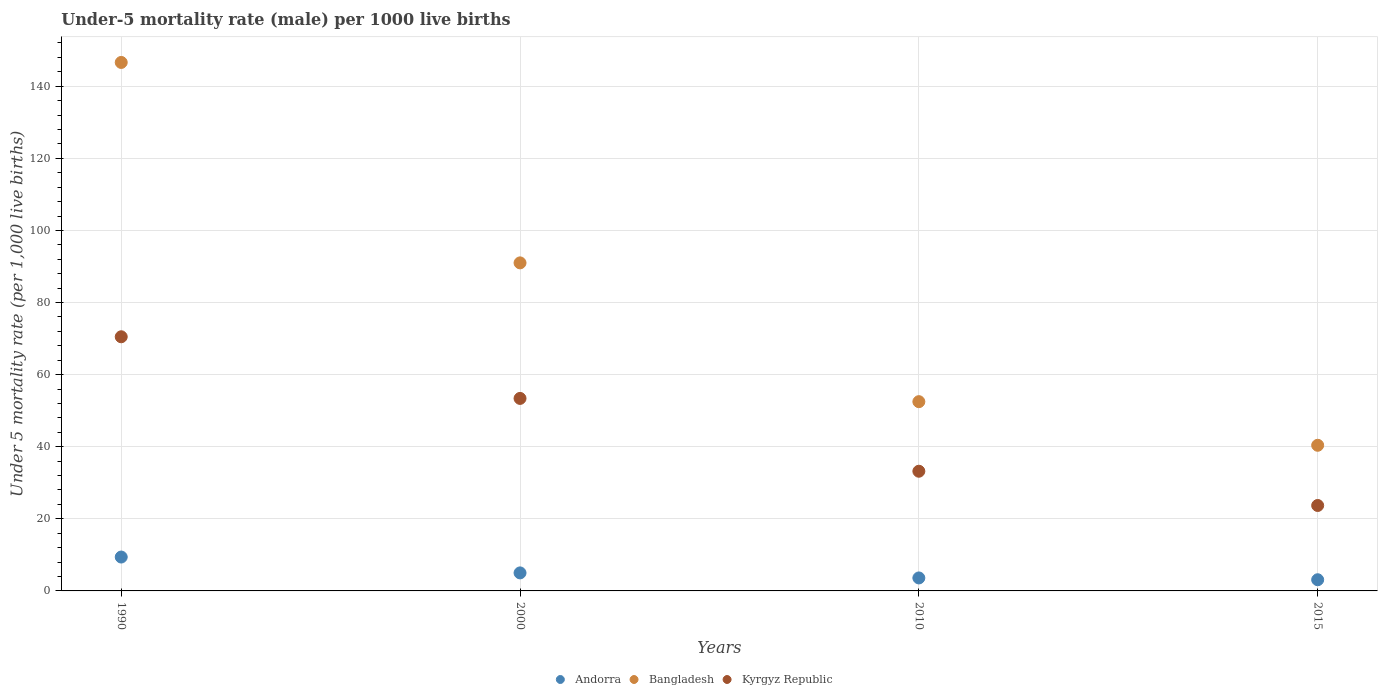How many different coloured dotlines are there?
Offer a very short reply. 3. What is the under-five mortality rate in Andorra in 2015?
Your response must be concise. 3.1. Across all years, what is the maximum under-five mortality rate in Kyrgyz Republic?
Your response must be concise. 70.5. Across all years, what is the minimum under-five mortality rate in Kyrgyz Republic?
Your answer should be compact. 23.7. In which year was the under-five mortality rate in Andorra maximum?
Offer a very short reply. 1990. In which year was the under-five mortality rate in Kyrgyz Republic minimum?
Your answer should be compact. 2015. What is the total under-five mortality rate in Andorra in the graph?
Offer a very short reply. 21.1. What is the difference between the under-five mortality rate in Bangladesh in 2010 and that in 2015?
Provide a short and direct response. 12.1. What is the difference between the under-five mortality rate in Andorra in 2000 and the under-five mortality rate in Kyrgyz Republic in 1990?
Keep it short and to the point. -65.5. What is the average under-five mortality rate in Andorra per year?
Provide a succinct answer. 5.28. In the year 2015, what is the difference between the under-five mortality rate in Bangladesh and under-five mortality rate in Andorra?
Offer a terse response. 37.3. In how many years, is the under-five mortality rate in Bangladesh greater than 36?
Keep it short and to the point. 4. What is the ratio of the under-five mortality rate in Kyrgyz Republic in 2000 to that in 2010?
Provide a short and direct response. 1.61. Is the under-five mortality rate in Kyrgyz Republic in 2000 less than that in 2015?
Offer a very short reply. No. Is the difference between the under-five mortality rate in Bangladesh in 2000 and 2010 greater than the difference between the under-five mortality rate in Andorra in 2000 and 2010?
Make the answer very short. Yes. What is the difference between the highest and the lowest under-five mortality rate in Andorra?
Offer a terse response. 6.3. Is the sum of the under-five mortality rate in Andorra in 1990 and 2015 greater than the maximum under-five mortality rate in Kyrgyz Republic across all years?
Your answer should be very brief. No. Is it the case that in every year, the sum of the under-five mortality rate in Andorra and under-five mortality rate in Bangladesh  is greater than the under-five mortality rate in Kyrgyz Republic?
Provide a succinct answer. Yes. Is the under-five mortality rate in Andorra strictly less than the under-five mortality rate in Bangladesh over the years?
Keep it short and to the point. Yes. How many dotlines are there?
Make the answer very short. 3. Does the graph contain grids?
Give a very brief answer. Yes. Where does the legend appear in the graph?
Make the answer very short. Bottom center. How are the legend labels stacked?
Give a very brief answer. Horizontal. What is the title of the graph?
Ensure brevity in your answer.  Under-5 mortality rate (male) per 1000 live births. What is the label or title of the X-axis?
Keep it short and to the point. Years. What is the label or title of the Y-axis?
Your answer should be compact. Under 5 mortality rate (per 1,0 live births). What is the Under 5 mortality rate (per 1,000 live births) of Andorra in 1990?
Offer a very short reply. 9.4. What is the Under 5 mortality rate (per 1,000 live births) of Bangladesh in 1990?
Your response must be concise. 146.6. What is the Under 5 mortality rate (per 1,000 live births) in Kyrgyz Republic in 1990?
Give a very brief answer. 70.5. What is the Under 5 mortality rate (per 1,000 live births) in Andorra in 2000?
Offer a terse response. 5. What is the Under 5 mortality rate (per 1,000 live births) in Bangladesh in 2000?
Ensure brevity in your answer.  91. What is the Under 5 mortality rate (per 1,000 live births) of Kyrgyz Republic in 2000?
Your answer should be very brief. 53.4. What is the Under 5 mortality rate (per 1,000 live births) of Bangladesh in 2010?
Make the answer very short. 52.5. What is the Under 5 mortality rate (per 1,000 live births) of Kyrgyz Republic in 2010?
Your answer should be very brief. 33.2. What is the Under 5 mortality rate (per 1,000 live births) in Bangladesh in 2015?
Offer a terse response. 40.4. What is the Under 5 mortality rate (per 1,000 live births) of Kyrgyz Republic in 2015?
Keep it short and to the point. 23.7. Across all years, what is the maximum Under 5 mortality rate (per 1,000 live births) in Andorra?
Give a very brief answer. 9.4. Across all years, what is the maximum Under 5 mortality rate (per 1,000 live births) of Bangladesh?
Your response must be concise. 146.6. Across all years, what is the maximum Under 5 mortality rate (per 1,000 live births) in Kyrgyz Republic?
Provide a succinct answer. 70.5. Across all years, what is the minimum Under 5 mortality rate (per 1,000 live births) in Andorra?
Your response must be concise. 3.1. Across all years, what is the minimum Under 5 mortality rate (per 1,000 live births) of Bangladesh?
Ensure brevity in your answer.  40.4. Across all years, what is the minimum Under 5 mortality rate (per 1,000 live births) of Kyrgyz Republic?
Your answer should be very brief. 23.7. What is the total Under 5 mortality rate (per 1,000 live births) in Andorra in the graph?
Provide a short and direct response. 21.1. What is the total Under 5 mortality rate (per 1,000 live births) of Bangladesh in the graph?
Give a very brief answer. 330.5. What is the total Under 5 mortality rate (per 1,000 live births) of Kyrgyz Republic in the graph?
Provide a short and direct response. 180.8. What is the difference between the Under 5 mortality rate (per 1,000 live births) in Bangladesh in 1990 and that in 2000?
Make the answer very short. 55.6. What is the difference between the Under 5 mortality rate (per 1,000 live births) of Kyrgyz Republic in 1990 and that in 2000?
Provide a succinct answer. 17.1. What is the difference between the Under 5 mortality rate (per 1,000 live births) of Andorra in 1990 and that in 2010?
Provide a succinct answer. 5.8. What is the difference between the Under 5 mortality rate (per 1,000 live births) in Bangladesh in 1990 and that in 2010?
Your answer should be compact. 94.1. What is the difference between the Under 5 mortality rate (per 1,000 live births) of Kyrgyz Republic in 1990 and that in 2010?
Offer a very short reply. 37.3. What is the difference between the Under 5 mortality rate (per 1,000 live births) in Bangladesh in 1990 and that in 2015?
Your answer should be compact. 106.2. What is the difference between the Under 5 mortality rate (per 1,000 live births) of Kyrgyz Republic in 1990 and that in 2015?
Offer a terse response. 46.8. What is the difference between the Under 5 mortality rate (per 1,000 live births) of Andorra in 2000 and that in 2010?
Give a very brief answer. 1.4. What is the difference between the Under 5 mortality rate (per 1,000 live births) of Bangladesh in 2000 and that in 2010?
Your answer should be compact. 38.5. What is the difference between the Under 5 mortality rate (per 1,000 live births) of Kyrgyz Republic in 2000 and that in 2010?
Provide a short and direct response. 20.2. What is the difference between the Under 5 mortality rate (per 1,000 live births) of Andorra in 2000 and that in 2015?
Provide a short and direct response. 1.9. What is the difference between the Under 5 mortality rate (per 1,000 live births) in Bangladesh in 2000 and that in 2015?
Provide a short and direct response. 50.6. What is the difference between the Under 5 mortality rate (per 1,000 live births) of Kyrgyz Republic in 2000 and that in 2015?
Keep it short and to the point. 29.7. What is the difference between the Under 5 mortality rate (per 1,000 live births) of Andorra in 2010 and that in 2015?
Offer a terse response. 0.5. What is the difference between the Under 5 mortality rate (per 1,000 live births) in Bangladesh in 2010 and that in 2015?
Keep it short and to the point. 12.1. What is the difference between the Under 5 mortality rate (per 1,000 live births) of Kyrgyz Republic in 2010 and that in 2015?
Provide a succinct answer. 9.5. What is the difference between the Under 5 mortality rate (per 1,000 live births) of Andorra in 1990 and the Under 5 mortality rate (per 1,000 live births) of Bangladesh in 2000?
Offer a terse response. -81.6. What is the difference between the Under 5 mortality rate (per 1,000 live births) of Andorra in 1990 and the Under 5 mortality rate (per 1,000 live births) of Kyrgyz Republic in 2000?
Your answer should be compact. -44. What is the difference between the Under 5 mortality rate (per 1,000 live births) in Bangladesh in 1990 and the Under 5 mortality rate (per 1,000 live births) in Kyrgyz Republic in 2000?
Provide a succinct answer. 93.2. What is the difference between the Under 5 mortality rate (per 1,000 live births) of Andorra in 1990 and the Under 5 mortality rate (per 1,000 live births) of Bangladesh in 2010?
Offer a terse response. -43.1. What is the difference between the Under 5 mortality rate (per 1,000 live births) in Andorra in 1990 and the Under 5 mortality rate (per 1,000 live births) in Kyrgyz Republic in 2010?
Give a very brief answer. -23.8. What is the difference between the Under 5 mortality rate (per 1,000 live births) of Bangladesh in 1990 and the Under 5 mortality rate (per 1,000 live births) of Kyrgyz Republic in 2010?
Provide a succinct answer. 113.4. What is the difference between the Under 5 mortality rate (per 1,000 live births) of Andorra in 1990 and the Under 5 mortality rate (per 1,000 live births) of Bangladesh in 2015?
Give a very brief answer. -31. What is the difference between the Under 5 mortality rate (per 1,000 live births) of Andorra in 1990 and the Under 5 mortality rate (per 1,000 live births) of Kyrgyz Republic in 2015?
Keep it short and to the point. -14.3. What is the difference between the Under 5 mortality rate (per 1,000 live births) of Bangladesh in 1990 and the Under 5 mortality rate (per 1,000 live births) of Kyrgyz Republic in 2015?
Provide a succinct answer. 122.9. What is the difference between the Under 5 mortality rate (per 1,000 live births) in Andorra in 2000 and the Under 5 mortality rate (per 1,000 live births) in Bangladesh in 2010?
Give a very brief answer. -47.5. What is the difference between the Under 5 mortality rate (per 1,000 live births) of Andorra in 2000 and the Under 5 mortality rate (per 1,000 live births) of Kyrgyz Republic in 2010?
Offer a terse response. -28.2. What is the difference between the Under 5 mortality rate (per 1,000 live births) of Bangladesh in 2000 and the Under 5 mortality rate (per 1,000 live births) of Kyrgyz Republic in 2010?
Ensure brevity in your answer.  57.8. What is the difference between the Under 5 mortality rate (per 1,000 live births) in Andorra in 2000 and the Under 5 mortality rate (per 1,000 live births) in Bangladesh in 2015?
Provide a succinct answer. -35.4. What is the difference between the Under 5 mortality rate (per 1,000 live births) in Andorra in 2000 and the Under 5 mortality rate (per 1,000 live births) in Kyrgyz Republic in 2015?
Offer a very short reply. -18.7. What is the difference between the Under 5 mortality rate (per 1,000 live births) in Bangladesh in 2000 and the Under 5 mortality rate (per 1,000 live births) in Kyrgyz Republic in 2015?
Your answer should be very brief. 67.3. What is the difference between the Under 5 mortality rate (per 1,000 live births) in Andorra in 2010 and the Under 5 mortality rate (per 1,000 live births) in Bangladesh in 2015?
Your response must be concise. -36.8. What is the difference between the Under 5 mortality rate (per 1,000 live births) of Andorra in 2010 and the Under 5 mortality rate (per 1,000 live births) of Kyrgyz Republic in 2015?
Keep it short and to the point. -20.1. What is the difference between the Under 5 mortality rate (per 1,000 live births) in Bangladesh in 2010 and the Under 5 mortality rate (per 1,000 live births) in Kyrgyz Republic in 2015?
Offer a terse response. 28.8. What is the average Under 5 mortality rate (per 1,000 live births) of Andorra per year?
Offer a terse response. 5.28. What is the average Under 5 mortality rate (per 1,000 live births) of Bangladesh per year?
Provide a succinct answer. 82.62. What is the average Under 5 mortality rate (per 1,000 live births) in Kyrgyz Republic per year?
Make the answer very short. 45.2. In the year 1990, what is the difference between the Under 5 mortality rate (per 1,000 live births) of Andorra and Under 5 mortality rate (per 1,000 live births) of Bangladesh?
Your answer should be compact. -137.2. In the year 1990, what is the difference between the Under 5 mortality rate (per 1,000 live births) of Andorra and Under 5 mortality rate (per 1,000 live births) of Kyrgyz Republic?
Your answer should be compact. -61.1. In the year 1990, what is the difference between the Under 5 mortality rate (per 1,000 live births) of Bangladesh and Under 5 mortality rate (per 1,000 live births) of Kyrgyz Republic?
Ensure brevity in your answer.  76.1. In the year 2000, what is the difference between the Under 5 mortality rate (per 1,000 live births) of Andorra and Under 5 mortality rate (per 1,000 live births) of Bangladesh?
Make the answer very short. -86. In the year 2000, what is the difference between the Under 5 mortality rate (per 1,000 live births) in Andorra and Under 5 mortality rate (per 1,000 live births) in Kyrgyz Republic?
Provide a short and direct response. -48.4. In the year 2000, what is the difference between the Under 5 mortality rate (per 1,000 live births) of Bangladesh and Under 5 mortality rate (per 1,000 live births) of Kyrgyz Republic?
Provide a succinct answer. 37.6. In the year 2010, what is the difference between the Under 5 mortality rate (per 1,000 live births) in Andorra and Under 5 mortality rate (per 1,000 live births) in Bangladesh?
Your answer should be compact. -48.9. In the year 2010, what is the difference between the Under 5 mortality rate (per 1,000 live births) of Andorra and Under 5 mortality rate (per 1,000 live births) of Kyrgyz Republic?
Ensure brevity in your answer.  -29.6. In the year 2010, what is the difference between the Under 5 mortality rate (per 1,000 live births) of Bangladesh and Under 5 mortality rate (per 1,000 live births) of Kyrgyz Republic?
Your answer should be compact. 19.3. In the year 2015, what is the difference between the Under 5 mortality rate (per 1,000 live births) in Andorra and Under 5 mortality rate (per 1,000 live births) in Bangladesh?
Offer a terse response. -37.3. In the year 2015, what is the difference between the Under 5 mortality rate (per 1,000 live births) in Andorra and Under 5 mortality rate (per 1,000 live births) in Kyrgyz Republic?
Give a very brief answer. -20.6. What is the ratio of the Under 5 mortality rate (per 1,000 live births) in Andorra in 1990 to that in 2000?
Provide a succinct answer. 1.88. What is the ratio of the Under 5 mortality rate (per 1,000 live births) in Bangladesh in 1990 to that in 2000?
Keep it short and to the point. 1.61. What is the ratio of the Under 5 mortality rate (per 1,000 live births) of Kyrgyz Republic in 1990 to that in 2000?
Your response must be concise. 1.32. What is the ratio of the Under 5 mortality rate (per 1,000 live births) in Andorra in 1990 to that in 2010?
Give a very brief answer. 2.61. What is the ratio of the Under 5 mortality rate (per 1,000 live births) of Bangladesh in 1990 to that in 2010?
Keep it short and to the point. 2.79. What is the ratio of the Under 5 mortality rate (per 1,000 live births) of Kyrgyz Republic in 1990 to that in 2010?
Keep it short and to the point. 2.12. What is the ratio of the Under 5 mortality rate (per 1,000 live births) in Andorra in 1990 to that in 2015?
Offer a very short reply. 3.03. What is the ratio of the Under 5 mortality rate (per 1,000 live births) in Bangladesh in 1990 to that in 2015?
Provide a short and direct response. 3.63. What is the ratio of the Under 5 mortality rate (per 1,000 live births) of Kyrgyz Republic in 1990 to that in 2015?
Offer a very short reply. 2.97. What is the ratio of the Under 5 mortality rate (per 1,000 live births) of Andorra in 2000 to that in 2010?
Your answer should be very brief. 1.39. What is the ratio of the Under 5 mortality rate (per 1,000 live births) of Bangladesh in 2000 to that in 2010?
Make the answer very short. 1.73. What is the ratio of the Under 5 mortality rate (per 1,000 live births) in Kyrgyz Republic in 2000 to that in 2010?
Offer a very short reply. 1.61. What is the ratio of the Under 5 mortality rate (per 1,000 live births) of Andorra in 2000 to that in 2015?
Offer a very short reply. 1.61. What is the ratio of the Under 5 mortality rate (per 1,000 live births) of Bangladesh in 2000 to that in 2015?
Offer a very short reply. 2.25. What is the ratio of the Under 5 mortality rate (per 1,000 live births) in Kyrgyz Republic in 2000 to that in 2015?
Make the answer very short. 2.25. What is the ratio of the Under 5 mortality rate (per 1,000 live births) in Andorra in 2010 to that in 2015?
Give a very brief answer. 1.16. What is the ratio of the Under 5 mortality rate (per 1,000 live births) in Bangladesh in 2010 to that in 2015?
Keep it short and to the point. 1.3. What is the ratio of the Under 5 mortality rate (per 1,000 live births) in Kyrgyz Republic in 2010 to that in 2015?
Offer a very short reply. 1.4. What is the difference between the highest and the second highest Under 5 mortality rate (per 1,000 live births) in Bangladesh?
Make the answer very short. 55.6. What is the difference between the highest and the second highest Under 5 mortality rate (per 1,000 live births) in Kyrgyz Republic?
Ensure brevity in your answer.  17.1. What is the difference between the highest and the lowest Under 5 mortality rate (per 1,000 live births) of Andorra?
Your answer should be compact. 6.3. What is the difference between the highest and the lowest Under 5 mortality rate (per 1,000 live births) in Bangladesh?
Give a very brief answer. 106.2. What is the difference between the highest and the lowest Under 5 mortality rate (per 1,000 live births) of Kyrgyz Republic?
Provide a succinct answer. 46.8. 